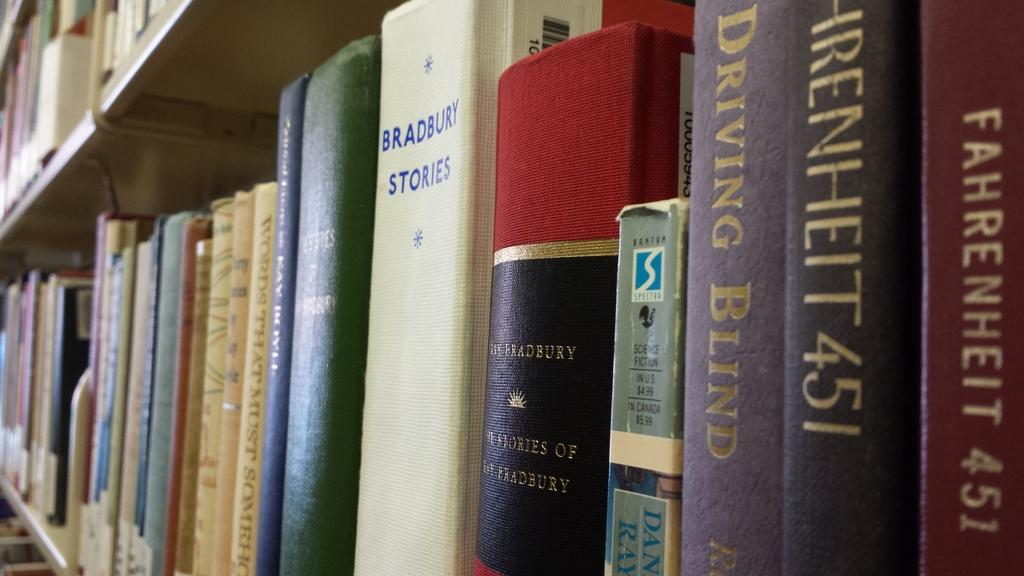Provide a one-sentence caption for the provided image. Several books are lined neatly on a shelf, including Fahrenheit 451. 